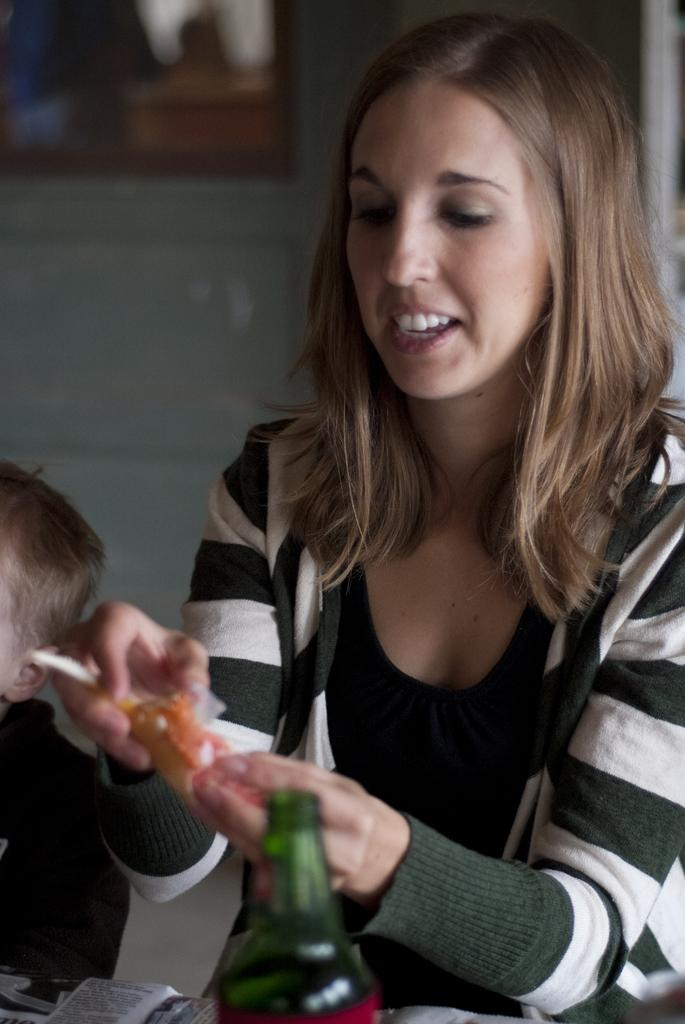Who is present in the image? There is a woman and a boy in the image. What is the woman holding in the image? The woman is holding an object. What can be seen on the table in the image? There is a table in the image, and there are objects on the table. What type of snake can be seen slithering across the table in the image? There is no snake present in the image; it only features a woman, a boy, a table, and objects on the table. 